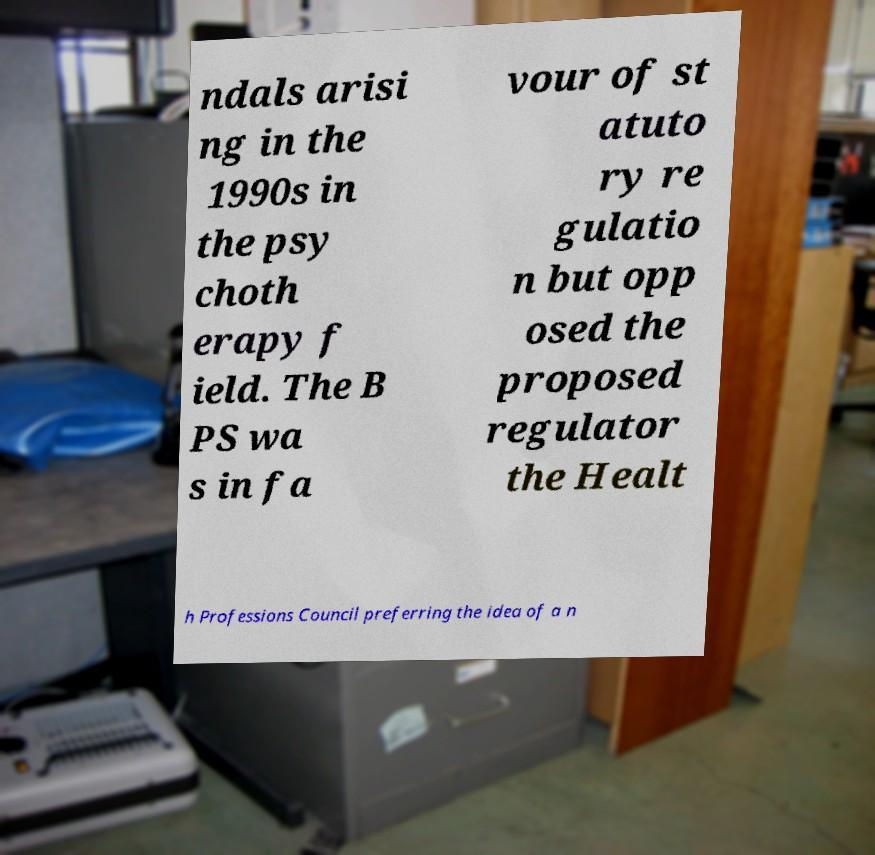Could you extract and type out the text from this image? ndals arisi ng in the 1990s in the psy choth erapy f ield. The B PS wa s in fa vour of st atuto ry re gulatio n but opp osed the proposed regulator the Healt h Professions Council preferring the idea of a n 